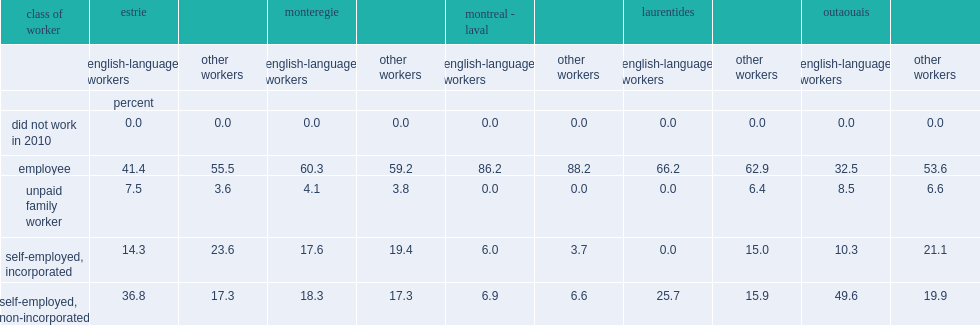Which region had the highest proportions of employees among all five agricultural regions of quebec in 2011? Montreal - laval. Which language group of workers were more likely to be self-employed in an unincorporated business in all of quebec's agricultural regions? english language workers or other workers? English-language workers. 